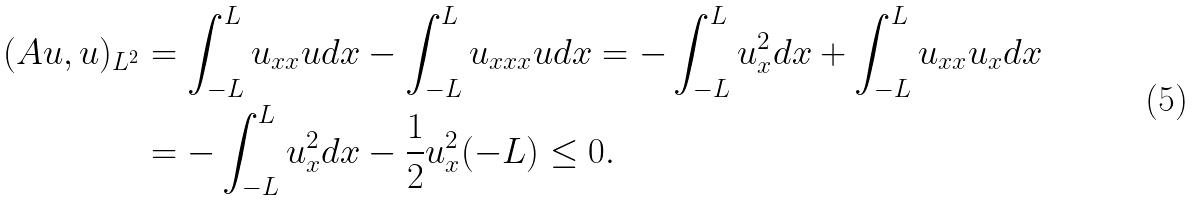Convert formula to latex. <formula><loc_0><loc_0><loc_500><loc_500>( A u , u ) _ { L ^ { 2 } } & = \int _ { - L } ^ { L } u _ { x x } u d x - \int _ { - L } ^ { L } u _ { x x x } u d x = - \int _ { - L } ^ { L } u _ { x } ^ { 2 } d x + \int _ { - L } ^ { L } u _ { x x } u _ { x } d x \\ & = - \int _ { - L } ^ { L } u _ { x } ^ { 2 } d x - \frac { 1 } { 2 } u _ { x } ^ { 2 } ( - L ) \leq 0 .</formula> 